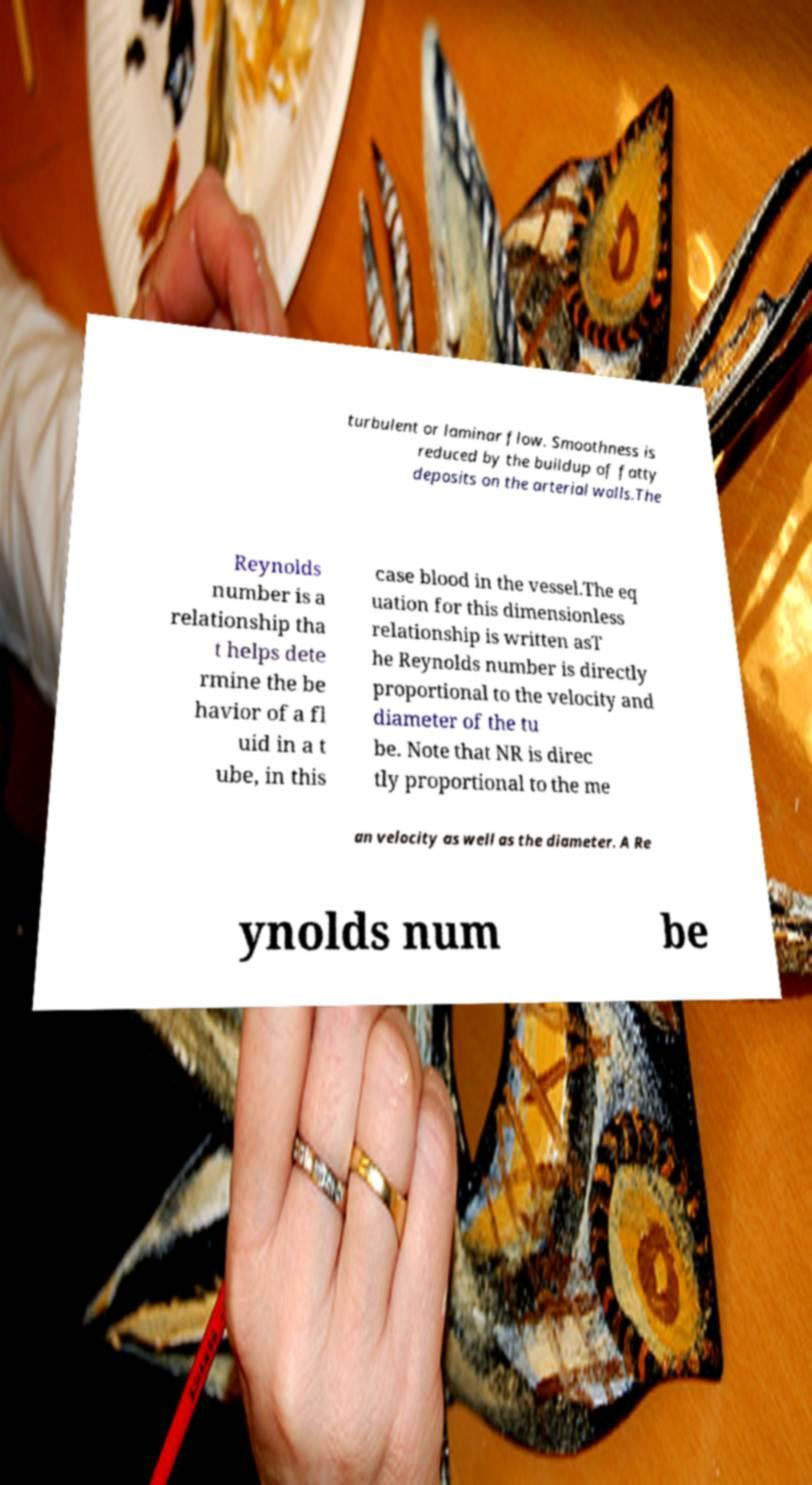What messages or text are displayed in this image? I need them in a readable, typed format. turbulent or laminar flow. Smoothness is reduced by the buildup of fatty deposits on the arterial walls.The Reynolds number is a relationship tha t helps dete rmine the be havior of a fl uid in a t ube, in this case blood in the vessel.The eq uation for this dimensionless relationship is written asT he Reynolds number is directly proportional to the velocity and diameter of the tu be. Note that NR is direc tly proportional to the me an velocity as well as the diameter. A Re ynolds num be 